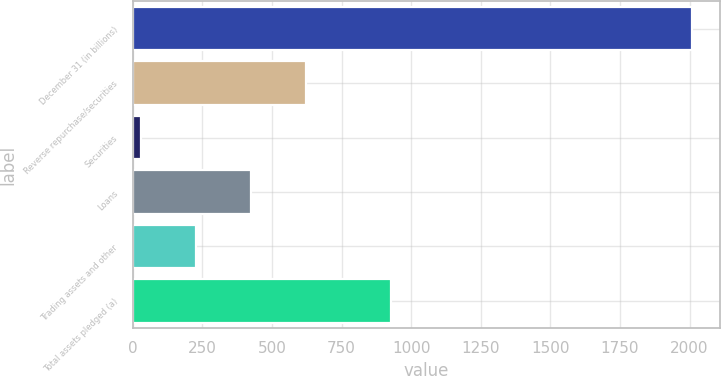<chart> <loc_0><loc_0><loc_500><loc_500><bar_chart><fcel>December 31 (in billions)<fcel>Reverse repurchase/securities<fcel>Securities<fcel>Loans<fcel>Trading assets and other<fcel>Total assets pledged (a)<nl><fcel>2008<fcel>624.1<fcel>31<fcel>426.4<fcel>228.7<fcel>927.9<nl></chart> 